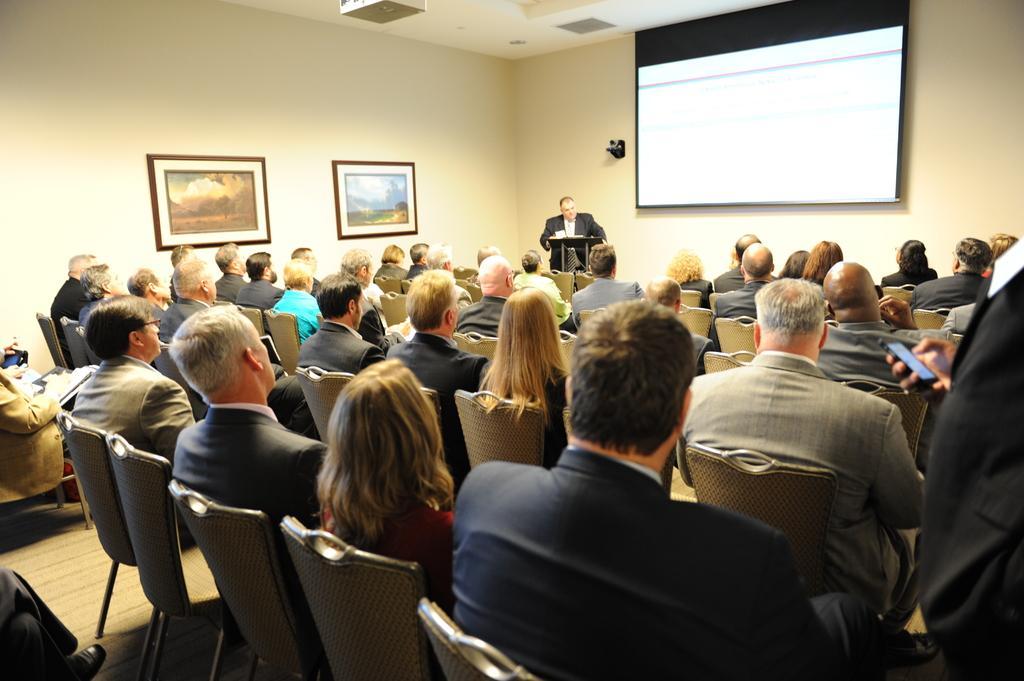Describe this image in one or two sentences. A group of people are sitting on the chairs in the middle a man is standing and speaking, on the right side there is a projector screen. 